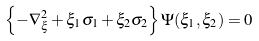Convert formula to latex. <formula><loc_0><loc_0><loc_500><loc_500>\left \{ - \nabla _ { \xi } ^ { 2 } + \xi _ { 1 } \sigma _ { 1 } + \xi _ { 2 } \sigma _ { 2 } \right \} \Psi ( \xi _ { 1 } , \xi _ { 2 } ) = 0</formula> 